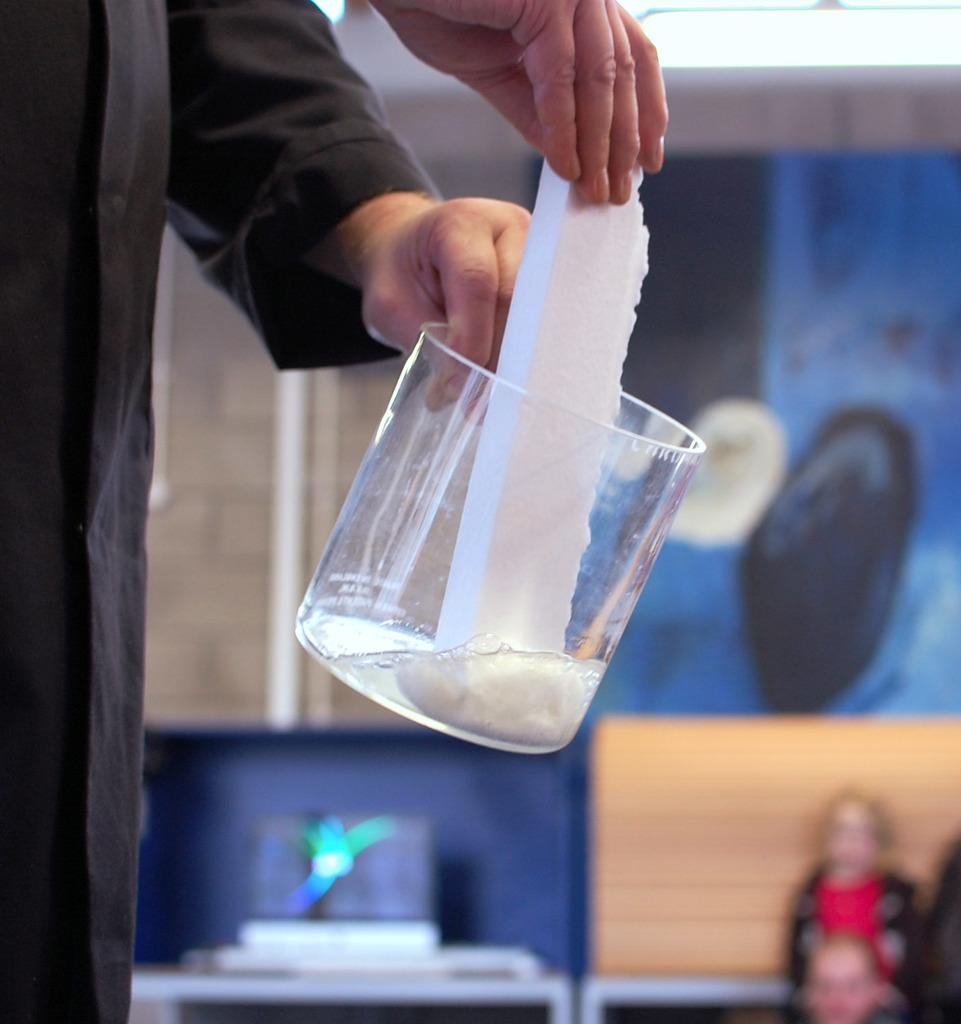What is the main subject of the image? There is a person standing in the image. What is the person doing in the image? The person is holding objects in their hands. Can you describe the background of the image? The background of the image is blurred. Are there any other objects visible in the image besides the person and their objects? Yes, there are other objects visible in the background of the image. What type of magic is the person performing in the image? There is no indication of magic or any magical activity in the image. The person is simply holding objects in their hands. 